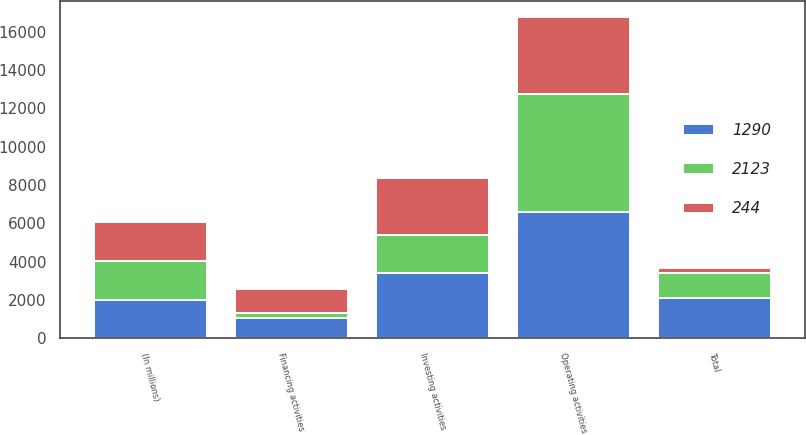<chart> <loc_0><loc_0><loc_500><loc_500><stacked_bar_chart><ecel><fcel>(In millions)<fcel>Operating activities<fcel>Investing activities<fcel>Financing activities<fcel>Total<nl><fcel>2123<fcel>2018<fcel>6158<fcel>2017.5<fcel>222<fcel>1290<nl><fcel>1290<fcel>2017<fcel>6612<fcel>3398<fcel>1091<fcel>2123<nl><fcel>244<fcel>2016<fcel>4017<fcel>2967<fcel>1294<fcel>244<nl></chart> 